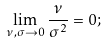<formula> <loc_0><loc_0><loc_500><loc_500>\lim _ { \nu , \sigma \to 0 } \frac { \nu } { \sigma ^ { 2 } } = 0 ;</formula> 